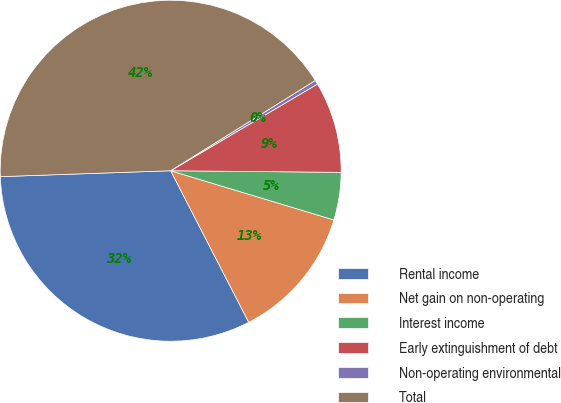Convert chart. <chart><loc_0><loc_0><loc_500><loc_500><pie_chart><fcel>Rental income<fcel>Net gain on non-operating<fcel>Interest income<fcel>Early extinguishment of debt<fcel>Non-operating environmental<fcel>Total<nl><fcel>32.02%<fcel>12.77%<fcel>4.51%<fcel>8.64%<fcel>0.39%<fcel>41.67%<nl></chart> 